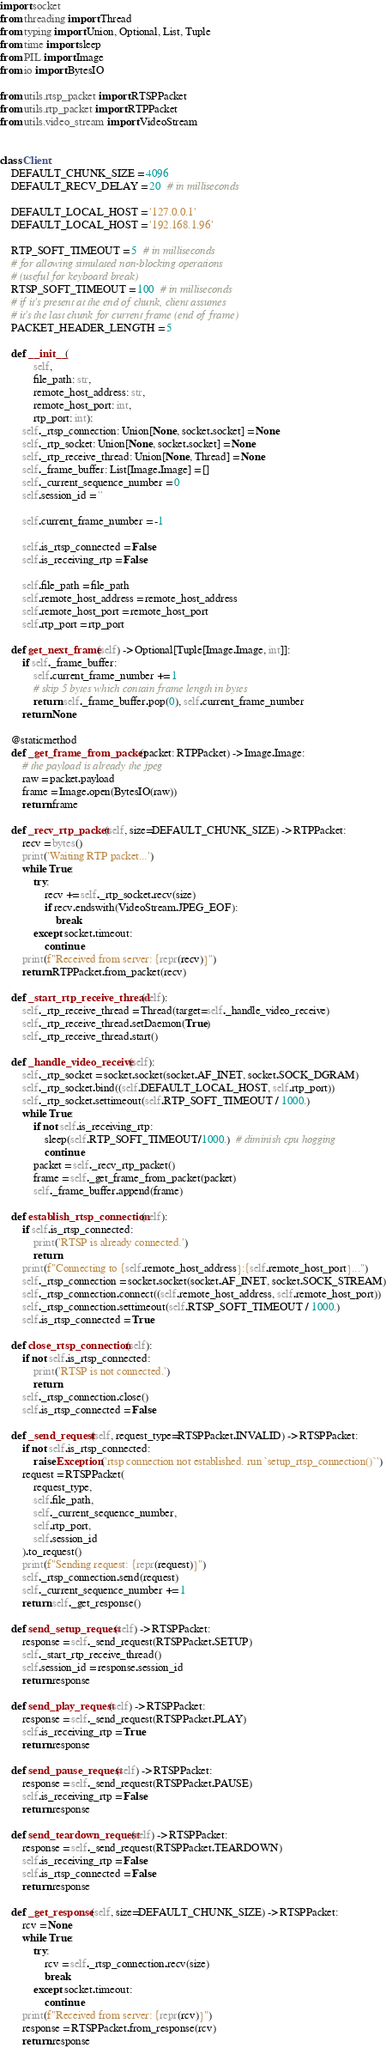Convert code to text. <code><loc_0><loc_0><loc_500><loc_500><_Python_>import socket
from threading import Thread
from typing import Union, Optional, List, Tuple
from time import sleep
from PIL import Image
from io import BytesIO

from utils.rtsp_packet import RTSPPacket
from utils.rtp_packet import RTPPacket
from utils.video_stream import VideoStream


class Client:
    DEFAULT_CHUNK_SIZE = 4096
    DEFAULT_RECV_DELAY = 20  # in milliseconds

    DEFAULT_LOCAL_HOST = '127.0.0.1'
    DEFAULT_LOCAL_HOST = '192.168.1.96'

    RTP_SOFT_TIMEOUT = 5  # in milliseconds
    # for allowing simulated non-blocking operations
    # (useful for keyboard break)
    RTSP_SOFT_TIMEOUT = 100  # in milliseconds
    # if it's present at the end of chunk, client assumes
    # it's the last chunk for current frame (end of frame)
    PACKET_HEADER_LENGTH = 5

    def __init__(
            self,
            file_path: str,
            remote_host_address: str,
            remote_host_port: int,
            rtp_port: int):
        self._rtsp_connection: Union[None, socket.socket] = None
        self._rtp_socket: Union[None, socket.socket] = None
        self._rtp_receive_thread: Union[None, Thread] = None
        self._frame_buffer: List[Image.Image] = []
        self._current_sequence_number = 0
        self.session_id = ''

        self.current_frame_number = -1

        self.is_rtsp_connected = False
        self.is_receiving_rtp = False

        self.file_path = file_path
        self.remote_host_address = remote_host_address
        self.remote_host_port = remote_host_port
        self.rtp_port = rtp_port

    def get_next_frame(self) -> Optional[Tuple[Image.Image, int]]:
        if self._frame_buffer:
            self.current_frame_number += 1
            # skip 5 bytes which contain frame length in bytes
            return self._frame_buffer.pop(0), self.current_frame_number
        return None

    @staticmethod
    def _get_frame_from_packet(packet: RTPPacket) -> Image.Image:
        # the payload is already the jpeg
        raw = packet.payload
        frame = Image.open(BytesIO(raw))
        return frame

    def _recv_rtp_packet(self, size=DEFAULT_CHUNK_SIZE) -> RTPPacket:
        recv = bytes()
        print('Waiting RTP packet...')
        while True:
            try:
                recv += self._rtp_socket.recv(size)
                if recv.endswith(VideoStream.JPEG_EOF):
                    break
            except socket.timeout:
                continue
        print(f"Received from server: {repr(recv)}")
        return RTPPacket.from_packet(recv)

    def _start_rtp_receive_thread(self):
        self._rtp_receive_thread = Thread(target=self._handle_video_receive)
        self._rtp_receive_thread.setDaemon(True)
        self._rtp_receive_thread.start()

    def _handle_video_receive(self):
        self._rtp_socket = socket.socket(socket.AF_INET, socket.SOCK_DGRAM)
        self._rtp_socket.bind((self.DEFAULT_LOCAL_HOST, self.rtp_port))
        self._rtp_socket.settimeout(self.RTP_SOFT_TIMEOUT / 1000.)
        while True:
            if not self.is_receiving_rtp:
                sleep(self.RTP_SOFT_TIMEOUT/1000.)  # diminish cpu hogging
                continue
            packet = self._recv_rtp_packet()
            frame = self._get_frame_from_packet(packet)
            self._frame_buffer.append(frame)

    def establish_rtsp_connection(self):
        if self.is_rtsp_connected:
            print('RTSP is already connected.')
            return
        print(f"Connecting to {self.remote_host_address}:{self.remote_host_port}...")
        self._rtsp_connection = socket.socket(socket.AF_INET, socket.SOCK_STREAM)
        self._rtsp_connection.connect((self.remote_host_address, self.remote_host_port))
        self._rtsp_connection.settimeout(self.RTSP_SOFT_TIMEOUT / 1000.)
        self.is_rtsp_connected = True

    def close_rtsp_connection(self):
        if not self.is_rtsp_connected:
            print('RTSP is not connected.')
            return
        self._rtsp_connection.close()
        self.is_rtsp_connected = False

    def _send_request(self, request_type=RTSPPacket.INVALID) -> RTSPPacket:
        if not self.is_rtsp_connected:
            raise Exception('rtsp connection not established. run `setup_rtsp_connection()`')
        request = RTSPPacket(
            request_type,
            self.file_path,
            self._current_sequence_number,
            self.rtp_port,
            self.session_id
        ).to_request()
        print(f"Sending request: {repr(request)}")
        self._rtsp_connection.send(request)
        self._current_sequence_number += 1
        return self._get_response()

    def send_setup_request(self) -> RTSPPacket:
        response = self._send_request(RTSPPacket.SETUP)
        self._start_rtp_receive_thread()
        self.session_id = response.session_id
        return response

    def send_play_request(self) -> RTSPPacket:
        response = self._send_request(RTSPPacket.PLAY)
        self.is_receiving_rtp = True
        return response

    def send_pause_request(self) -> RTSPPacket:
        response = self._send_request(RTSPPacket.PAUSE)
        self.is_receiving_rtp = False
        return response

    def send_teardown_request(self) -> RTSPPacket:
        response = self._send_request(RTSPPacket.TEARDOWN)
        self.is_receiving_rtp = False
        self.is_rtsp_connected = False
        return response

    def _get_response(self, size=DEFAULT_CHUNK_SIZE) -> RTSPPacket:
        rcv = None
        while True:
            try:
                rcv = self._rtsp_connection.recv(size)
                break
            except socket.timeout:
                continue
        print(f"Received from server: {repr(rcv)}")
        response = RTSPPacket.from_response(rcv)
        return response
</code> 